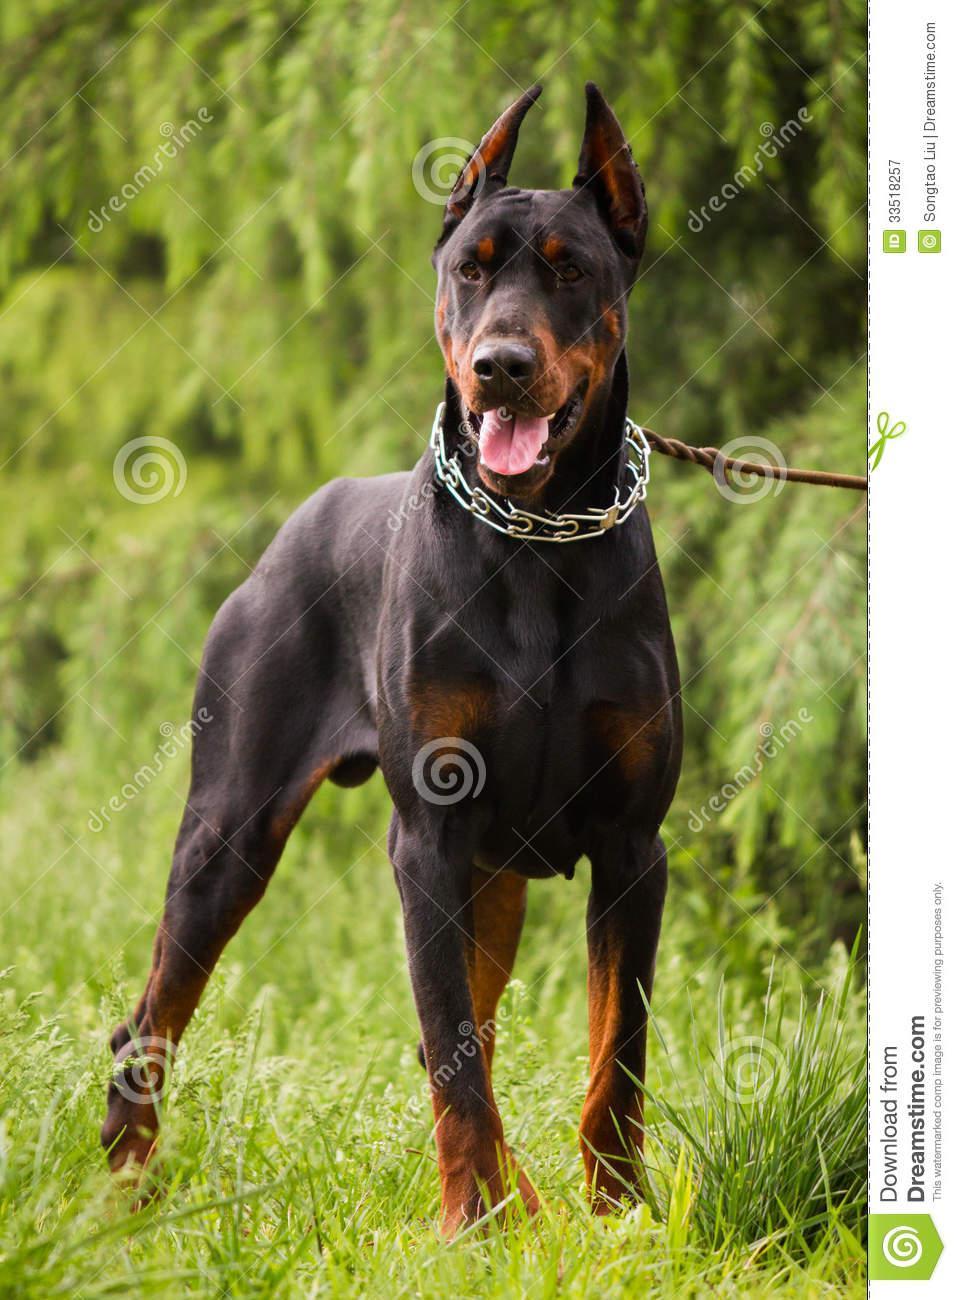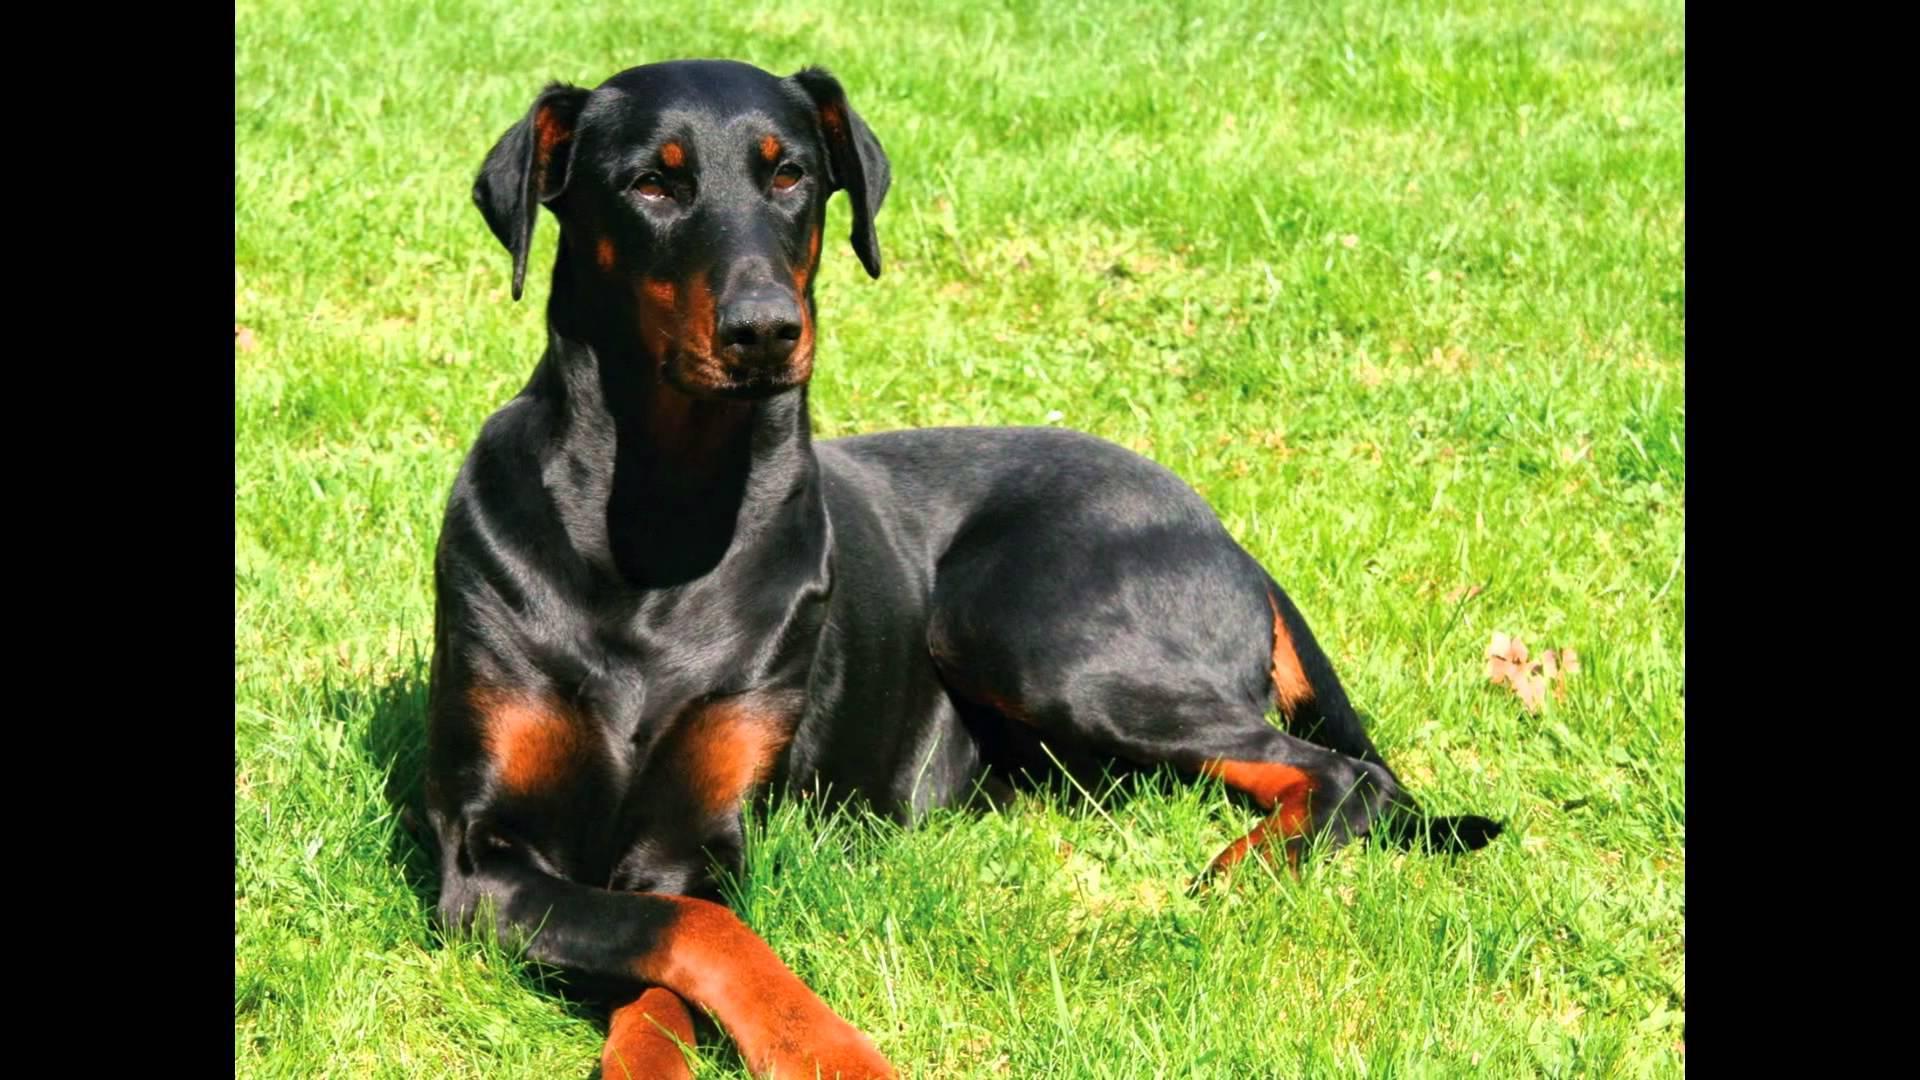The first image is the image on the left, the second image is the image on the right. For the images shown, is this caption "There is one dog without a collar" true? Answer yes or no. Yes. The first image is the image on the left, the second image is the image on the right. Considering the images on both sides, is "There are a total of 4 dogs sitting in pairs." valid? Answer yes or no. No. 